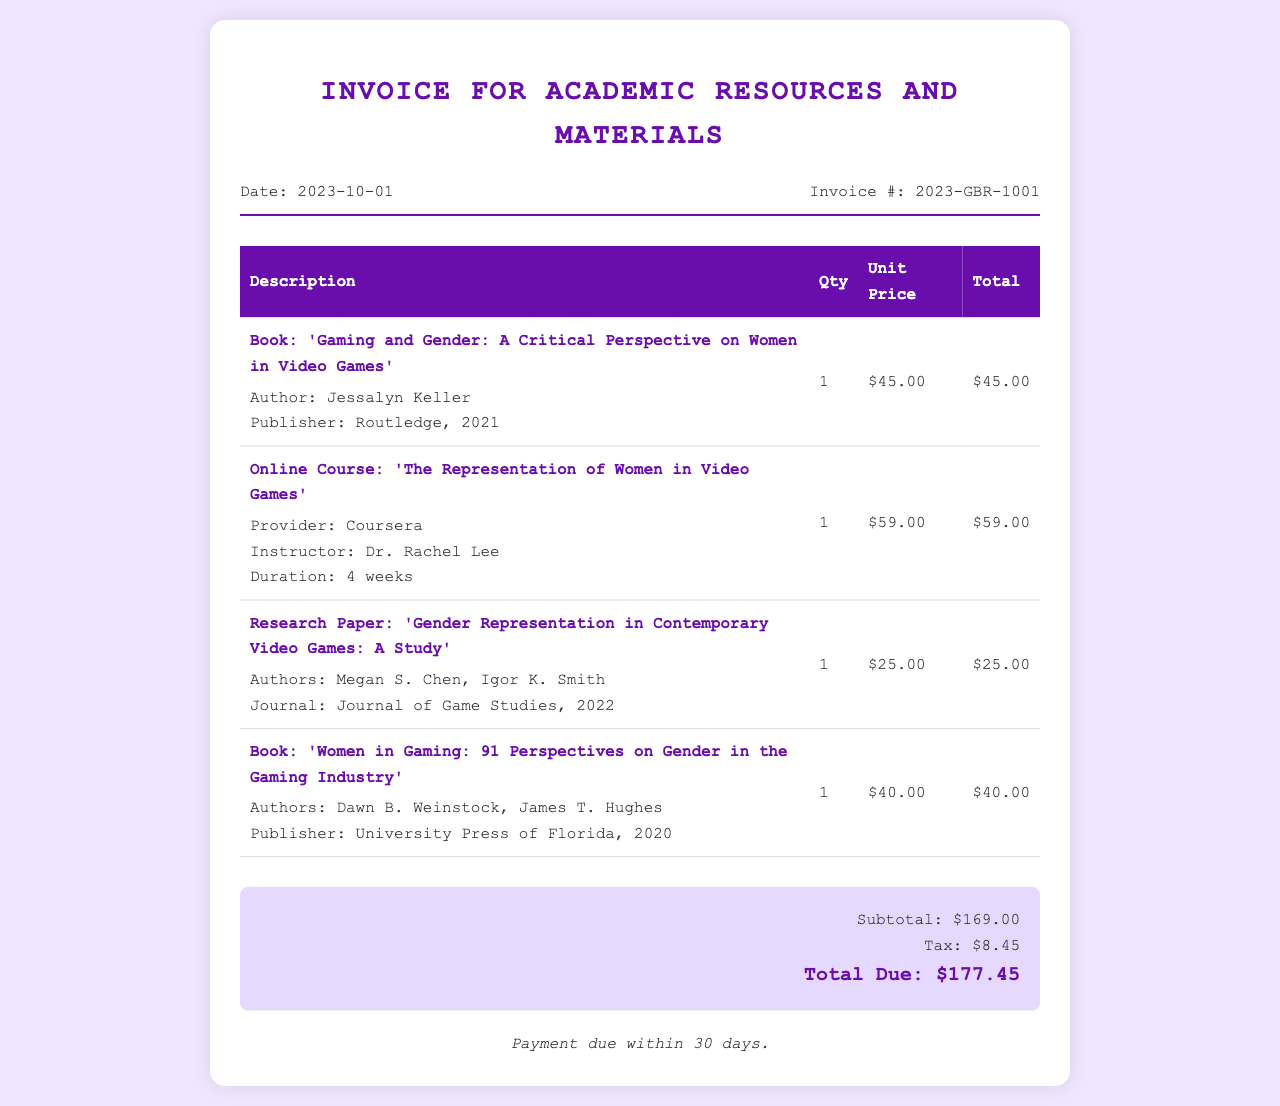What is the date of the invoice? The date of the invoice is specified in the header of the document.
Answer: 2023-10-01 What is the invoice number? The invoice number is indicated in the header section of the document.
Answer: 2023-GBR-1001 What is the total due amount? The total due amount is calculated and presented in the summary section of the document.
Answer: $177.45 Who is the author of the book 'Gaming and Gender'? The author's name is found within the item description for the corresponding book.
Answer: Jessalyn Keller How many online courses were purchased? The quantity can be found in the items section related to online courses.
Answer: 1 What is the tax amount on this invoice? The tax amount is provided in the summary section of the invoice.
Answer: $8.45 Which company published the book 'Women in Gaming'? The publisher is listed in the item description for that specific book.
Answer: University Press of Florida What is the duration of the online course? The duration is specified in the item details for the online course.
Answer: 4 weeks What is the subtotal before tax? The subtotal is stated in the summary section prior to tax.
Answer: $169.00 